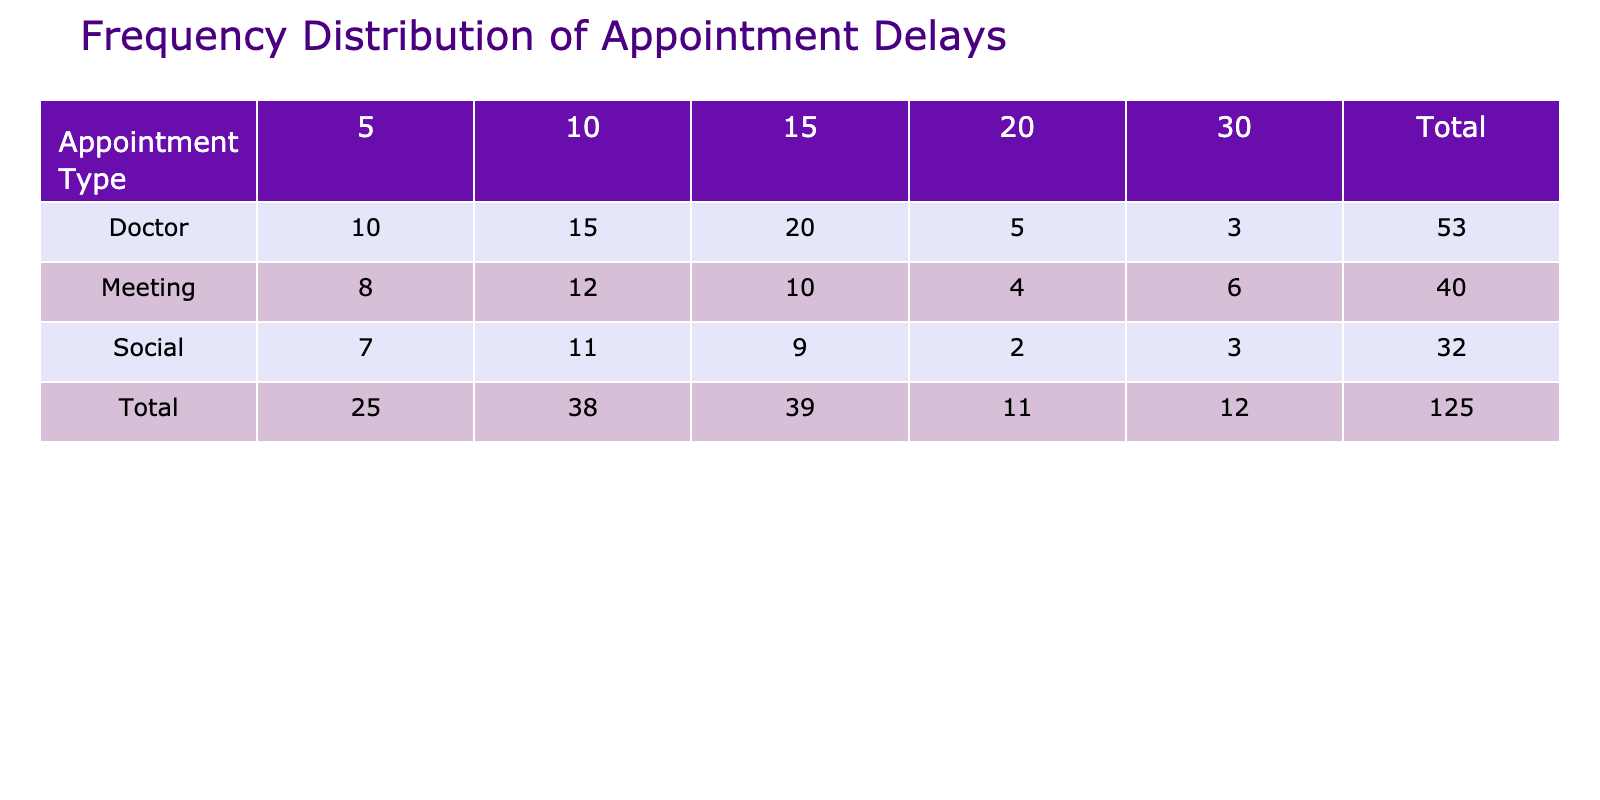What is the total frequency of appointments that had a delay of 10 minutes? To find the total frequency of appointments with a delay of 10 minutes, I need to look at the frequency values under the 10 minutes delay for each appointment type: Doctor (15), Meeting (12), and Social (11). Add them together: 15 + 12 + 11 = 38.
Answer: 38 Which appointment type had the highest total frequency? The total frequency for each appointment type can be found by adding the frequencies for all delays within each type. For Doctor: 10 + 15 + 20 + 5 + 3 = 53; Meeting: 8 + 12 + 10 + 4 + 6 = 40; Social: 7 + 11 + 9 + 2 + 3 = 32. The highest total frequency is for Doctor with 53.
Answer: Doctor Is there any appointment type that had a delay of 30 minutes? To answer this, I will check the table for the presence of a 30 minutes delay across the appointment types. Checking the table, I see that all three appointment types (Doctor, Meeting, and Social) have frequencies for a 30-minute delay, indicating that this is true.
Answer: Yes What is the average delay for Doctor appointments based on the provided data? First, I sum the delays weighted by their respective frequencies: (5*10 + 10*15 + 15*20 + 20*5 + 30*3) = 50 + 150 + 300 + 100 + 90 = 690. Next, I calculate the total frequency for Doctor appointments which is 10 + 15 + 20 + 5 + 3 = 53. The average delay is then total delay (690) divided by total frequency (53): 690 / 53 ≈ 13.02.
Answer: Approximately 13.02 How many total appointments were recorded with a delay of 20 minutes? I will sum the frequencies for all appointment types that have a delay of 20 minutes. This includes Doctor (5), Meeting (4), and Social (2). Adding these together gives 5 + 4 + 2 = 11.
Answer: 11 Which appointment type has the most frequency for a 5-minute delay? I look at the frequencies for a 5-minute delay in each appointment type: Doctor (10), Meeting (8), and Social (7). Comparing these values, Doctor has the highest frequency at 10.
Answer: Doctor How many total appointments had a delay of 15 minutes and what appointment type had the maximum in that category? I first add the frequencies for 15 minutes across appointment types: Doctor (20), Meeting (10), Social (9) gives 20 + 10 + 9 = 39. Next, I see that Doctor has the most frequency for the 15 minutes delay with 20.
Answer: 39; Doctor Is the total frequency for Meetings greater than the total frequency for Social appointments? First, I calculate the total frequency for both Meeting and Social. Meeting has a total of 40, while Social has a total of 32. Comparing these values, 40 is greater than 32, confirming the statement is correct.
Answer: Yes 